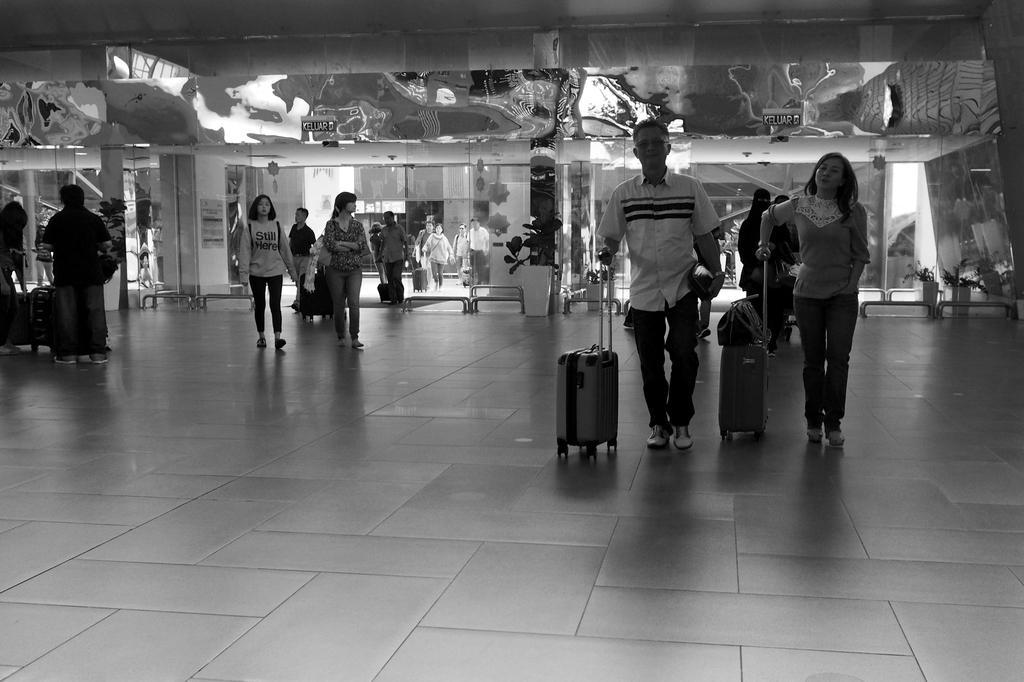Could you give a brief overview of what you see in this image? This is a black and white picture, in this image we can see a few people, among them some people are holding the trolley bags, there are some potted plants, glass doors and a board. 